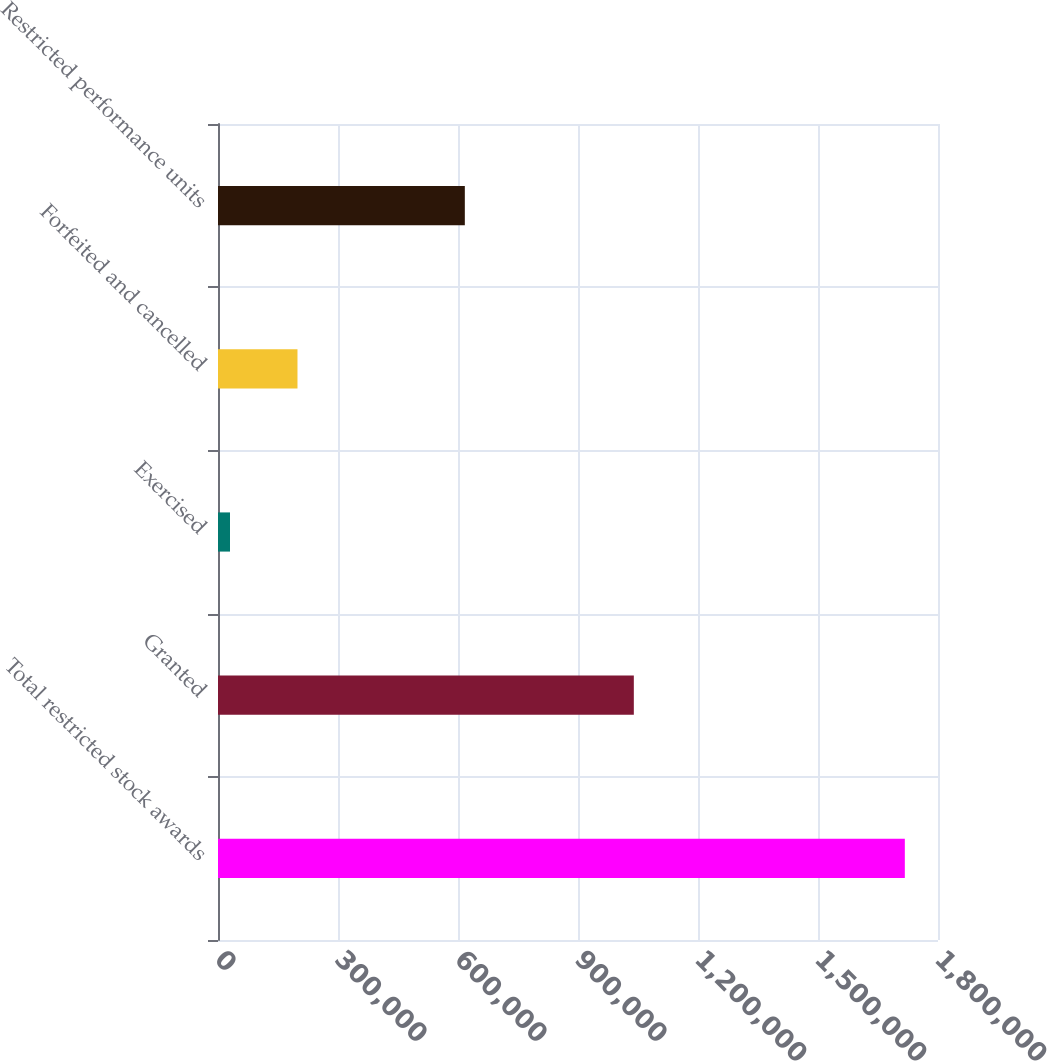<chart> <loc_0><loc_0><loc_500><loc_500><bar_chart><fcel>Total restricted stock awards<fcel>Granted<fcel>Exercised<fcel>Forfeited and cancelled<fcel>Restricted performance units<nl><fcel>1.71708e+06<fcel>1.03958e+06<fcel>30000<fcel>198708<fcel>617078<nl></chart> 